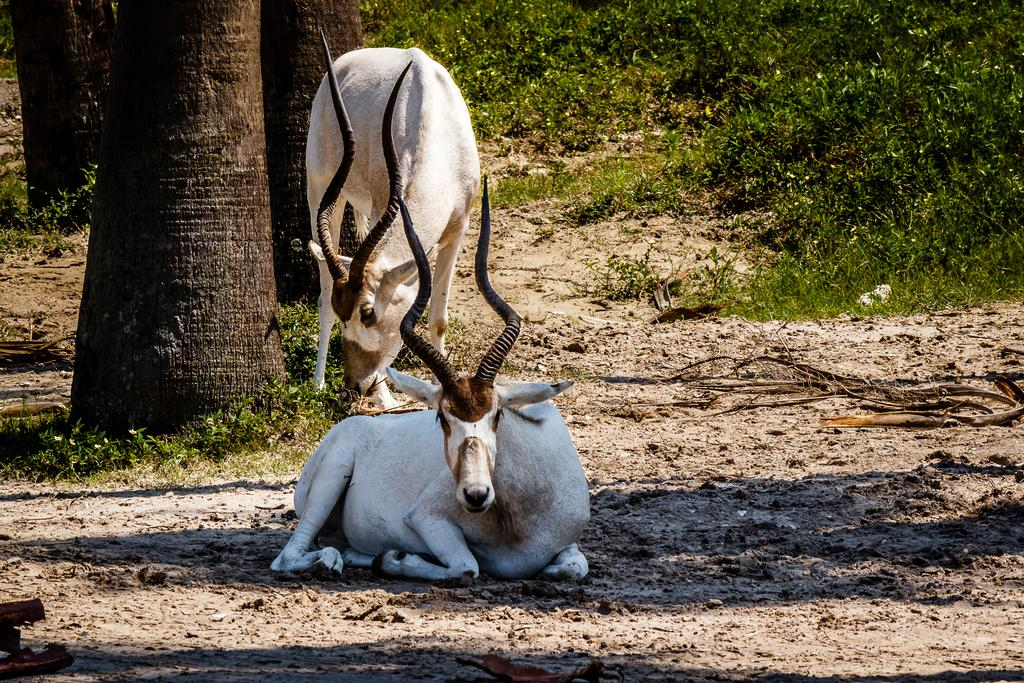How many animals can be seen in the image? There are two animals in the image. What is the ground surface like in the image? The ground is covered with grass. What type of natural feature can be seen in the image? There are tree trunks visible in the image. What type of hair can be seen on the animals in the image? There is no information about the animals' hair in the image, so it cannot be determined. 